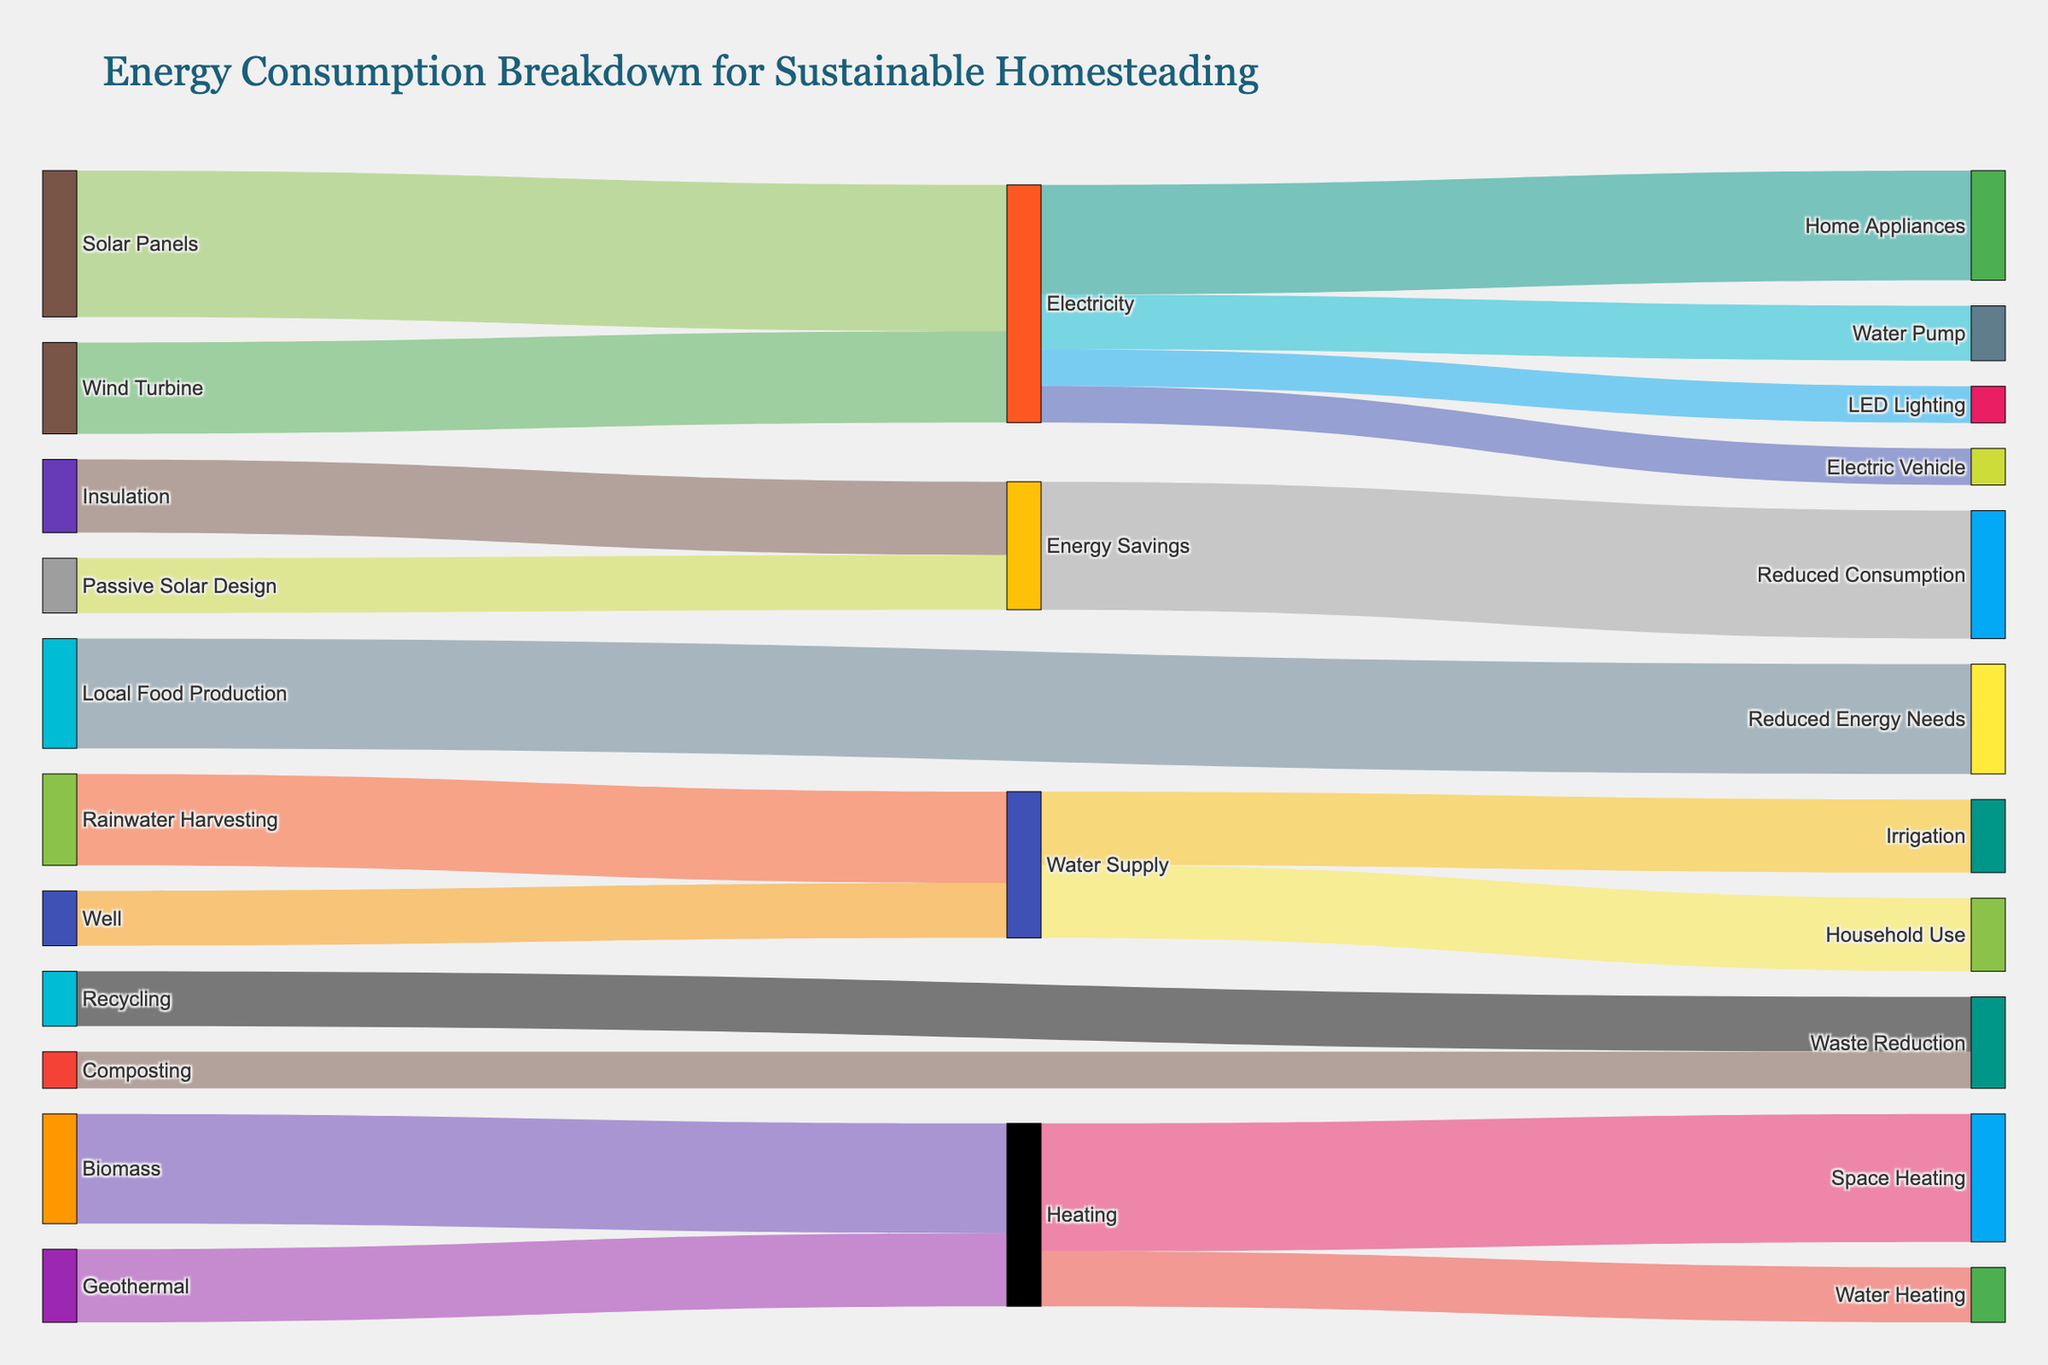Which energy source contributes the most to electricity generation? The Sankey diagram shows the contributions of different energy sources to electricity generation. By matching the sources to their respective values where the target is "Electricity," we see that the highest value is from Solar Panels.
Answer: Solar Panels What is the total value of electricity used in different applications? We need to sum up all the values where the target is related to electricity consumption: Home Appliances (30), Water Pump (15), LED Lighting (10), Electric Vehicle (10). Adding these together gives 30 + 15 + 10 + 10 = 65.
Answer: 65 Which application uses the least amount of electricity? By comparing the values targeted for different applications of electricity, we see that LED Lighting and Electric Vehicle both use 10 units, which is the lowest amount among the listed applications.
Answer: LED Lighting or Electric Vehicle How does the value for Water Heating compare to Space Heating? From the breakdown of Heating, we see that Space Heating has a value of 35, and Water Heating has a value of 15. Thus, Space Heating uses more energy than Water Heating.
Answer: Space Heating uses more What are the contributions to the Water Supply, and what is their total value? The Sankey diagram shows contributions to Water Supply from Rainwater Harvesting (25) and Well (15). Summing these values gives 25 + 15 = 40.
Answer: 40 What is the primary source for heating? Comparing the contributions to Heating from Biomass (30) and Geothermal (20), we find that Biomass is the primary source since it has a higher value of 30.
Answer: Biomass Which part of the Energy Savings has the higher value? Comparing Passive Solar Design (15) and Insulation (20), Insulation has the higher contribution to Energy Savings.
Answer: Insulation What is the combined effect on Reduced Energy Needs and Reduced Consumption? The diagram shows Local Food Production leading to Reduced Energy Needs (30) and Energy Savings leading to Reduced Consumption (35). Adding these together gives 30 + 35 = 65.
Answer: 65 Which waste reduction method has a greater impact? The values for Composting and Recycling are compared, with Composting at 10 and Recycling at 15. Thus, Recycling has a greater impact.
Answer: Recycling How much energy is saved through Reduced Consumption? By following the path from Energy Savings to Reduced Consumption, we see that Energy Savings contribute 35 units to Reduced Consumption.
Answer: 35 